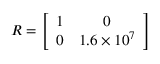Convert formula to latex. <formula><loc_0><loc_0><loc_500><loc_500>{ R } = \left [ \begin{array} { c c } { 1 } & { 0 } \\ { 0 } & { 1 . 6 \times 1 0 ^ { 7 } } \end{array} \right ]</formula> 